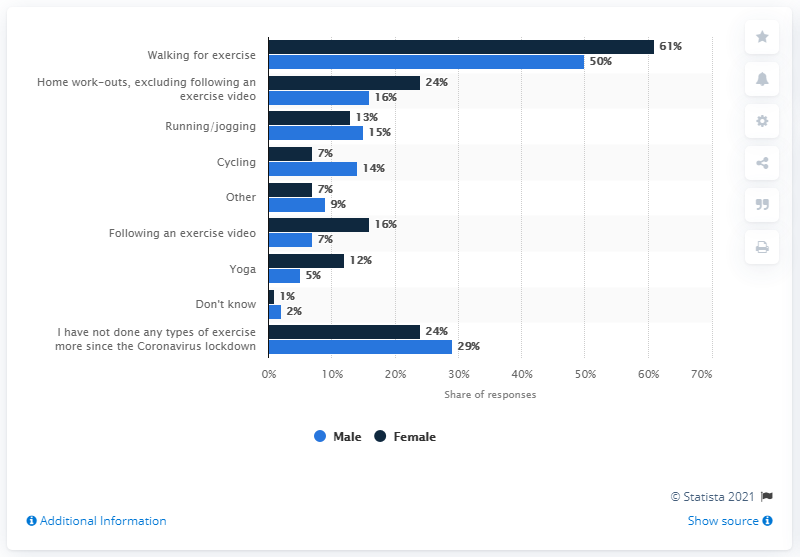Highlight a few significant elements in this photo. Since the lockdown, a significant portion of both women and men have been walking more frequently. Specifically, 50% of men and 61% of women have been walking more often. 